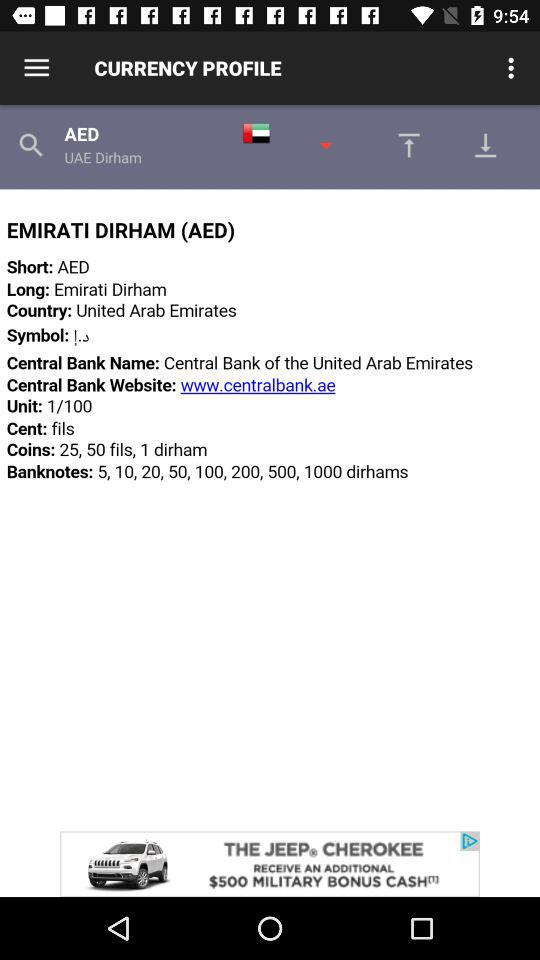How many fils are there in one dirham?
Answer the question using a single word or phrase. 100 